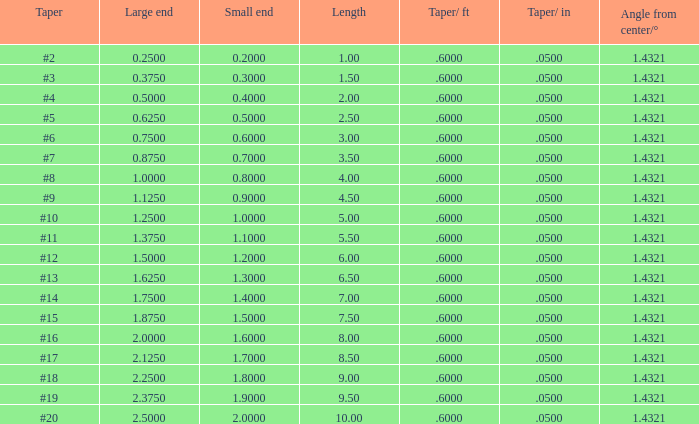Which Taper/in that has a Small end larger than 0.7000000000000001, and a Taper of #19, and a Large end larger than 2.375? None. 